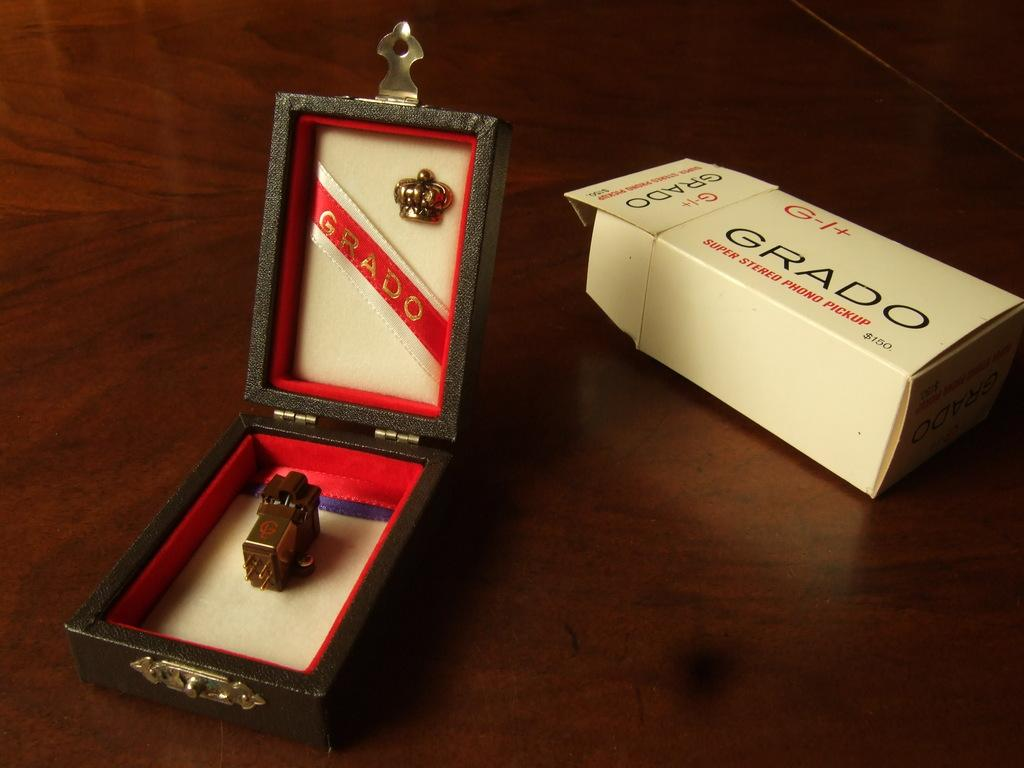<image>
Render a clear and concise summary of the photo. A Grado stereo phono pickup in a fancy jewelry type box. 